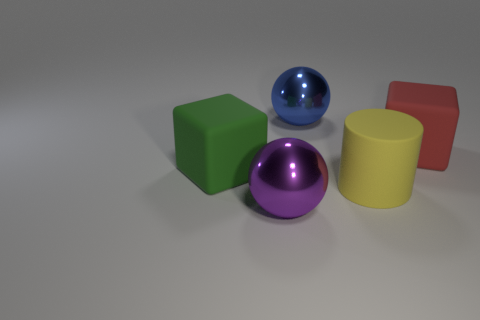Are there any other things that are the same shape as the yellow object?
Offer a terse response. No. Is there a large purple ball that has the same material as the blue thing?
Your response must be concise. Yes. The object that is in front of the big green rubber object and on the right side of the purple ball has what shape?
Give a very brief answer. Cylinder. What number of other things are there of the same shape as the purple thing?
Ensure brevity in your answer.  1. The blue thing is what size?
Your response must be concise. Large. How many things are either big red rubber blocks or large blue objects?
Keep it short and to the point. 2. There is a rubber thing on the right side of the yellow matte cylinder; what is its size?
Your answer should be very brief. Large. Is there any other thing that has the same size as the yellow rubber thing?
Keep it short and to the point. Yes. The big rubber thing that is on the right side of the blue thing and left of the red cube is what color?
Your response must be concise. Yellow. Is the material of the thing behind the red rubber block the same as the large purple ball?
Provide a succinct answer. Yes. 